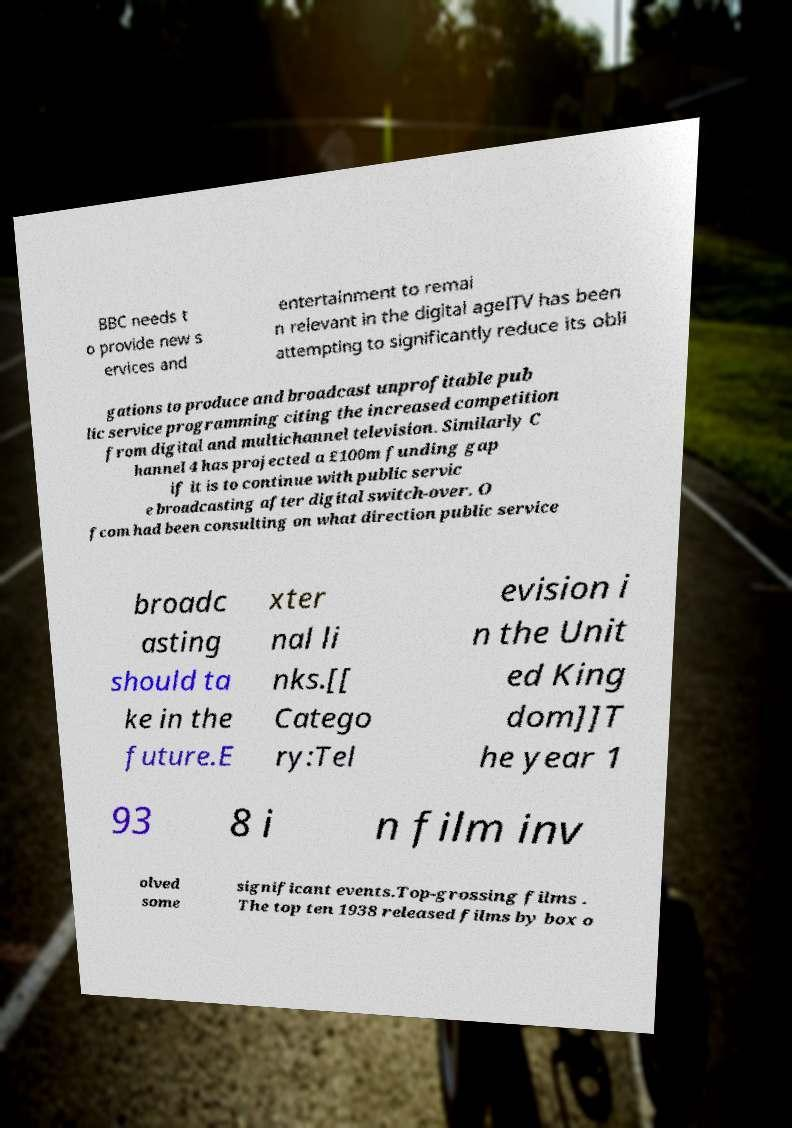I need the written content from this picture converted into text. Can you do that? BBC needs t o provide new s ervices and entertainment to remai n relevant in the digital ageITV has been attempting to significantly reduce its obli gations to produce and broadcast unprofitable pub lic service programming citing the increased competition from digital and multichannel television. Similarly C hannel 4 has projected a £100m funding gap if it is to continue with public servic e broadcasting after digital switch-over. O fcom had been consulting on what direction public service broadc asting should ta ke in the future.E xter nal li nks.[[ Catego ry:Tel evision i n the Unit ed King dom]]T he year 1 93 8 i n film inv olved some significant events.Top-grossing films . The top ten 1938 released films by box o 